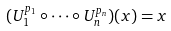Convert formula to latex. <formula><loc_0><loc_0><loc_500><loc_500>( U _ { 1 } ^ { p _ { 1 } } \circ \dots \circ U _ { n } ^ { p _ { n } } ) ( x ) = x</formula> 